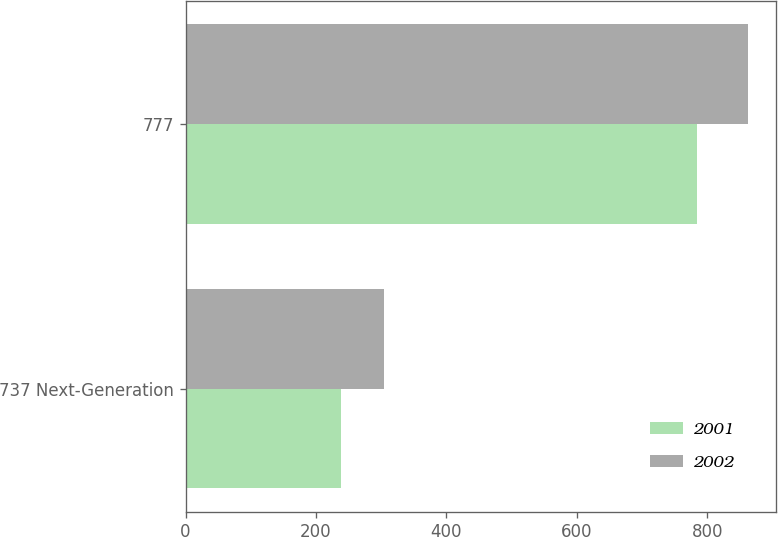Convert chart. <chart><loc_0><loc_0><loc_500><loc_500><stacked_bar_chart><ecel><fcel>737 Next-Generation<fcel>777<nl><fcel>2001<fcel>239<fcel>785<nl><fcel>2002<fcel>305<fcel>863<nl></chart> 